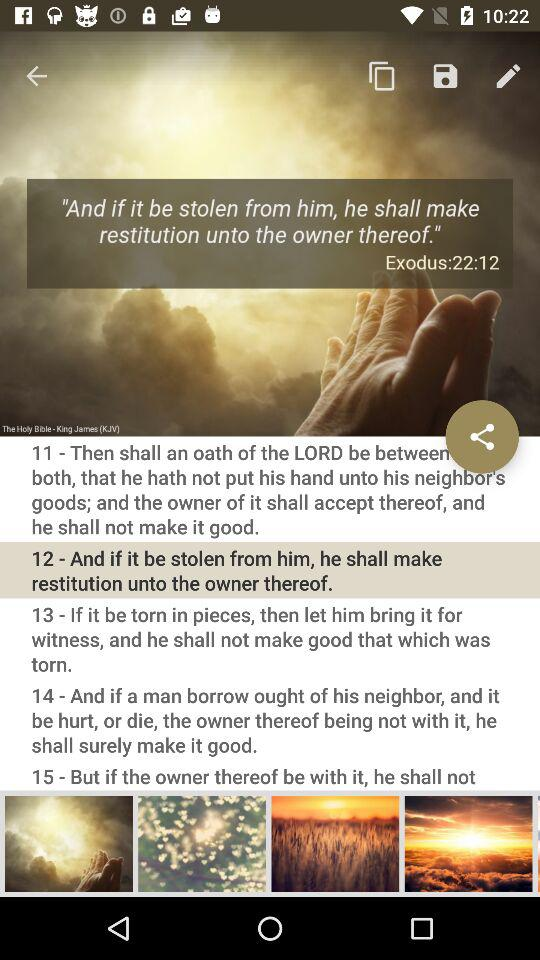How many more Bible verses are there after verse 12?
Answer the question using a single word or phrase. 3 